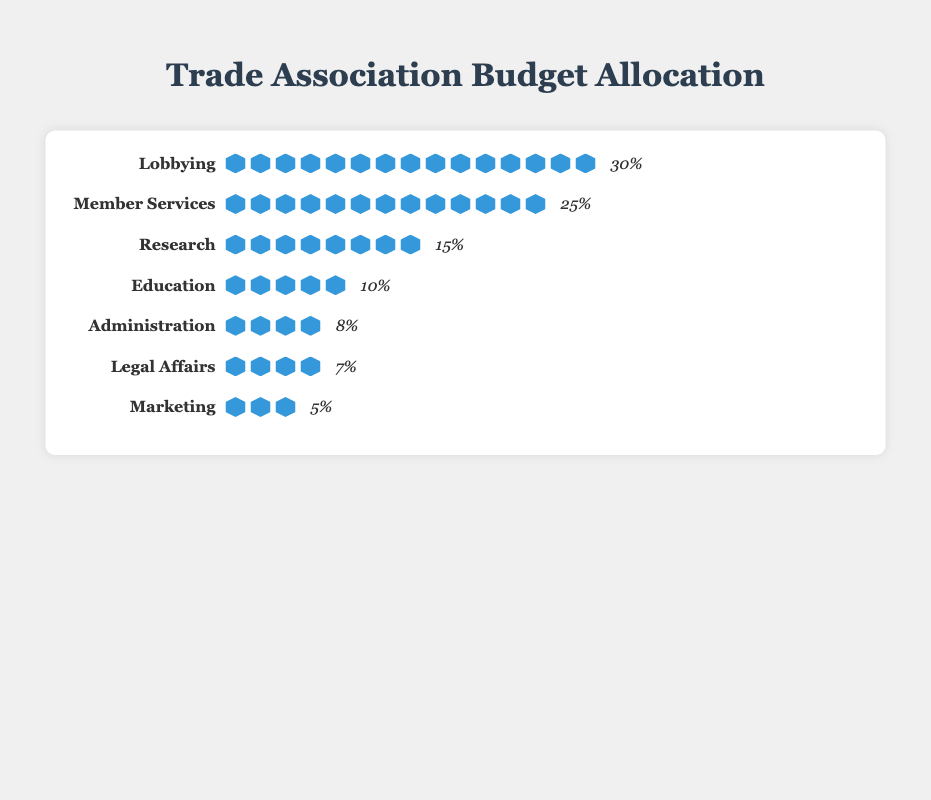What is the unit used to represent the budget allocation values? The unit used to represent the budget allocation values is displayed next to the percentages in the figure, showing "percentage".
Answer: percentage Which operational area has the highest budget allocation? The figure indicates that the "Lobbying" category has the highest number of dollar icons, also corroborated by the percentage value of 30%.
Answer: Lobbying How many operational areas have budget allocations equal to or greater than 10%? By counting the categories with percentages equal to or greater than 10% in the figure, we find there are four: "Lobbying" (30%), "Member Services" (25%), "Research" (15%), and "Education" (10%).
Answer: 4 What is the total budget allocation of the "Administration" and "Legal Affairs" categories combined? Adding the percentages for "Administration" (8%) and "Legal Affairs" (7%), the total allocation is 8% + 7% = 15%.
Answer: 15% Compare the budget allocations of "Member Services" and "Research". Which one is bigger and by how much? "Member Services" has a budget allocation of 25%, and "Research" has 15%. The difference is 25% - 15% = 10%.
Answer: Member Services, by 10% What percentage of the budget is allocated to categories with less than 10% each? Summing up the percentages for "Administration" (8%), "Legal Affairs" (7%), and "Marketing" (5%), the total is 8% + 7% + 5% = 20%.
Answer: 20% Which operational area has the smallest budget allocation and what is its percentage? The "Marketing" category has the fewest dollar icons, and its percentage is listed as 5%.
Answer: Marketing, 5% If the budget for "Education" were doubled, what would its new percentage be? The current budget for "Education" is 10%, so doubling it would be 10% * 2 = 20%.
Answer: 20% How does the budget allocation for "Research" compare to that of "Administration" and "Legal Affairs" combined? "Research" is allocated 15%, while the combined allocation for "Administration" (8%) and "Legal Affairs" (7%) is 8% + 7% = 15%. Therefore, they are equal.
Answer: They are equal 